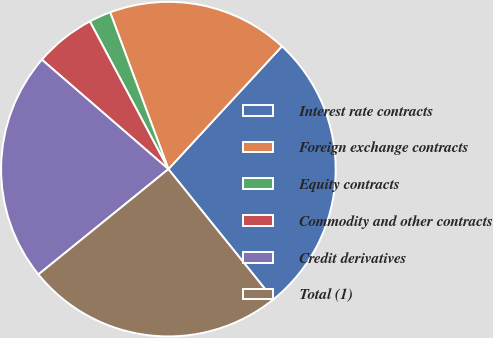Convert chart to OTSL. <chart><loc_0><loc_0><loc_500><loc_500><pie_chart><fcel>Interest rate contracts<fcel>Foreign exchange contracts<fcel>Equity contracts<fcel>Commodity and other contracts<fcel>Credit derivatives<fcel>Total (1)<nl><fcel>27.33%<fcel>17.53%<fcel>2.12%<fcel>5.87%<fcel>22.19%<fcel>24.96%<nl></chart> 